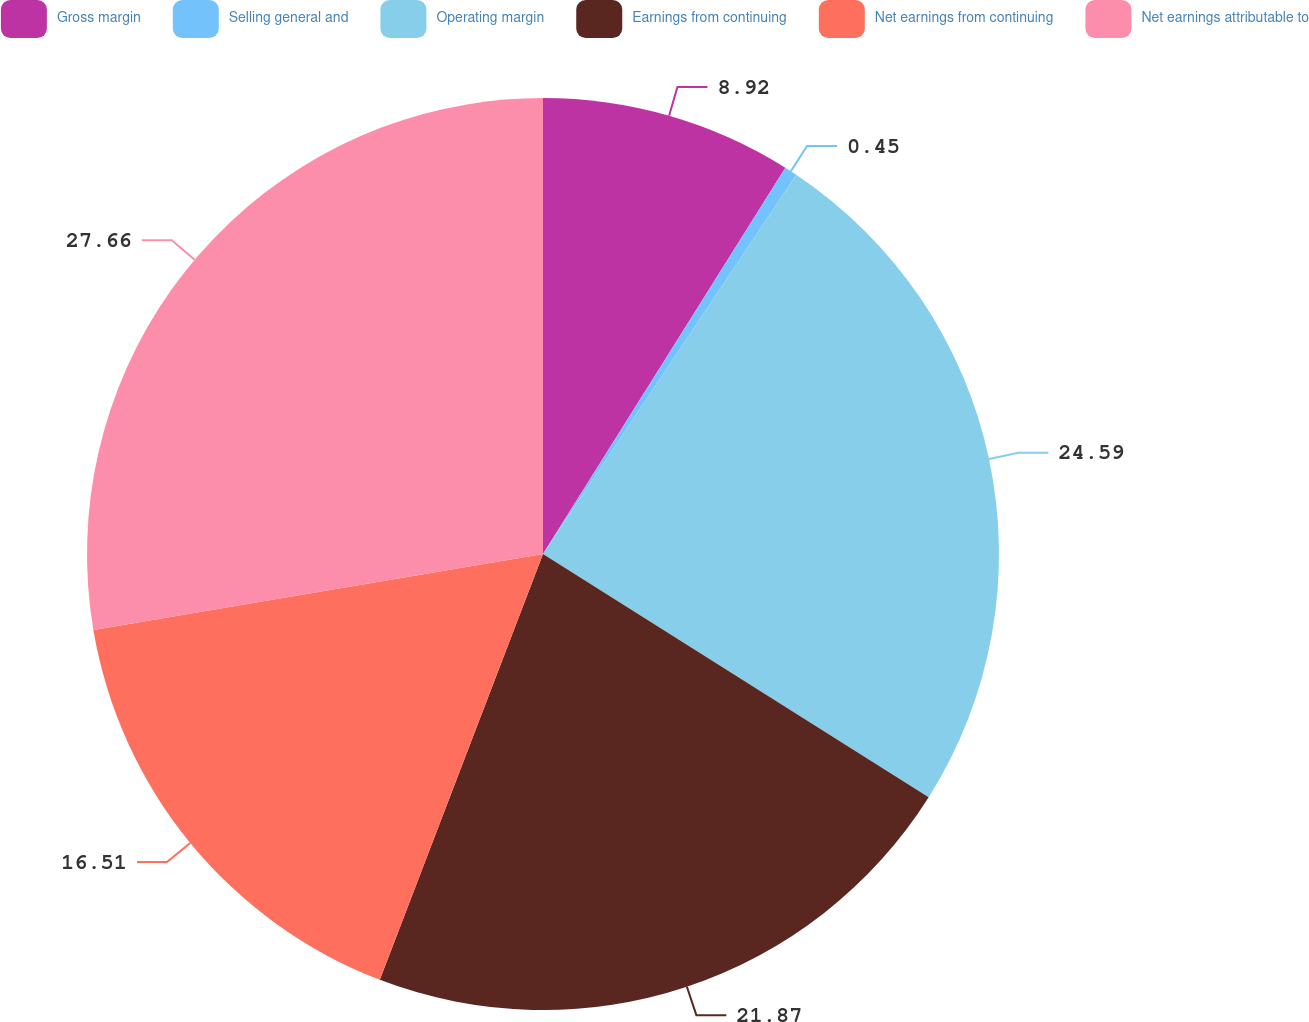Convert chart. <chart><loc_0><loc_0><loc_500><loc_500><pie_chart><fcel>Gross margin<fcel>Selling general and<fcel>Operating margin<fcel>Earnings from continuing<fcel>Net earnings from continuing<fcel>Net earnings attributable to<nl><fcel>8.92%<fcel>0.45%<fcel>24.59%<fcel>21.87%<fcel>16.51%<fcel>27.67%<nl></chart> 